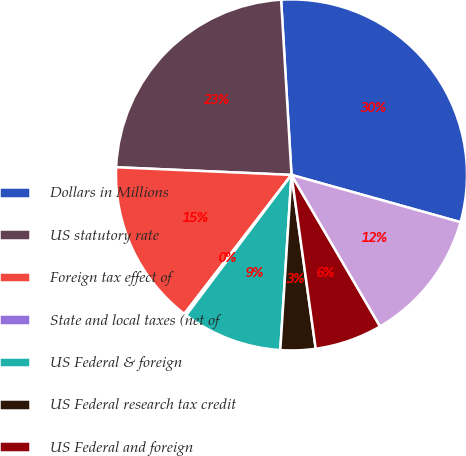Convert chart to OTSL. <chart><loc_0><loc_0><loc_500><loc_500><pie_chart><fcel>Dollars in Millions<fcel>US statutory rate<fcel>Foreign tax effect of<fcel>State and local taxes (net of<fcel>US Federal & foreign<fcel>US Federal research tax credit<fcel>US Federal and foreign<fcel>Foreign and other<nl><fcel>30.28%<fcel>23.36%<fcel>15.24%<fcel>0.21%<fcel>9.23%<fcel>3.22%<fcel>6.22%<fcel>12.24%<nl></chart> 